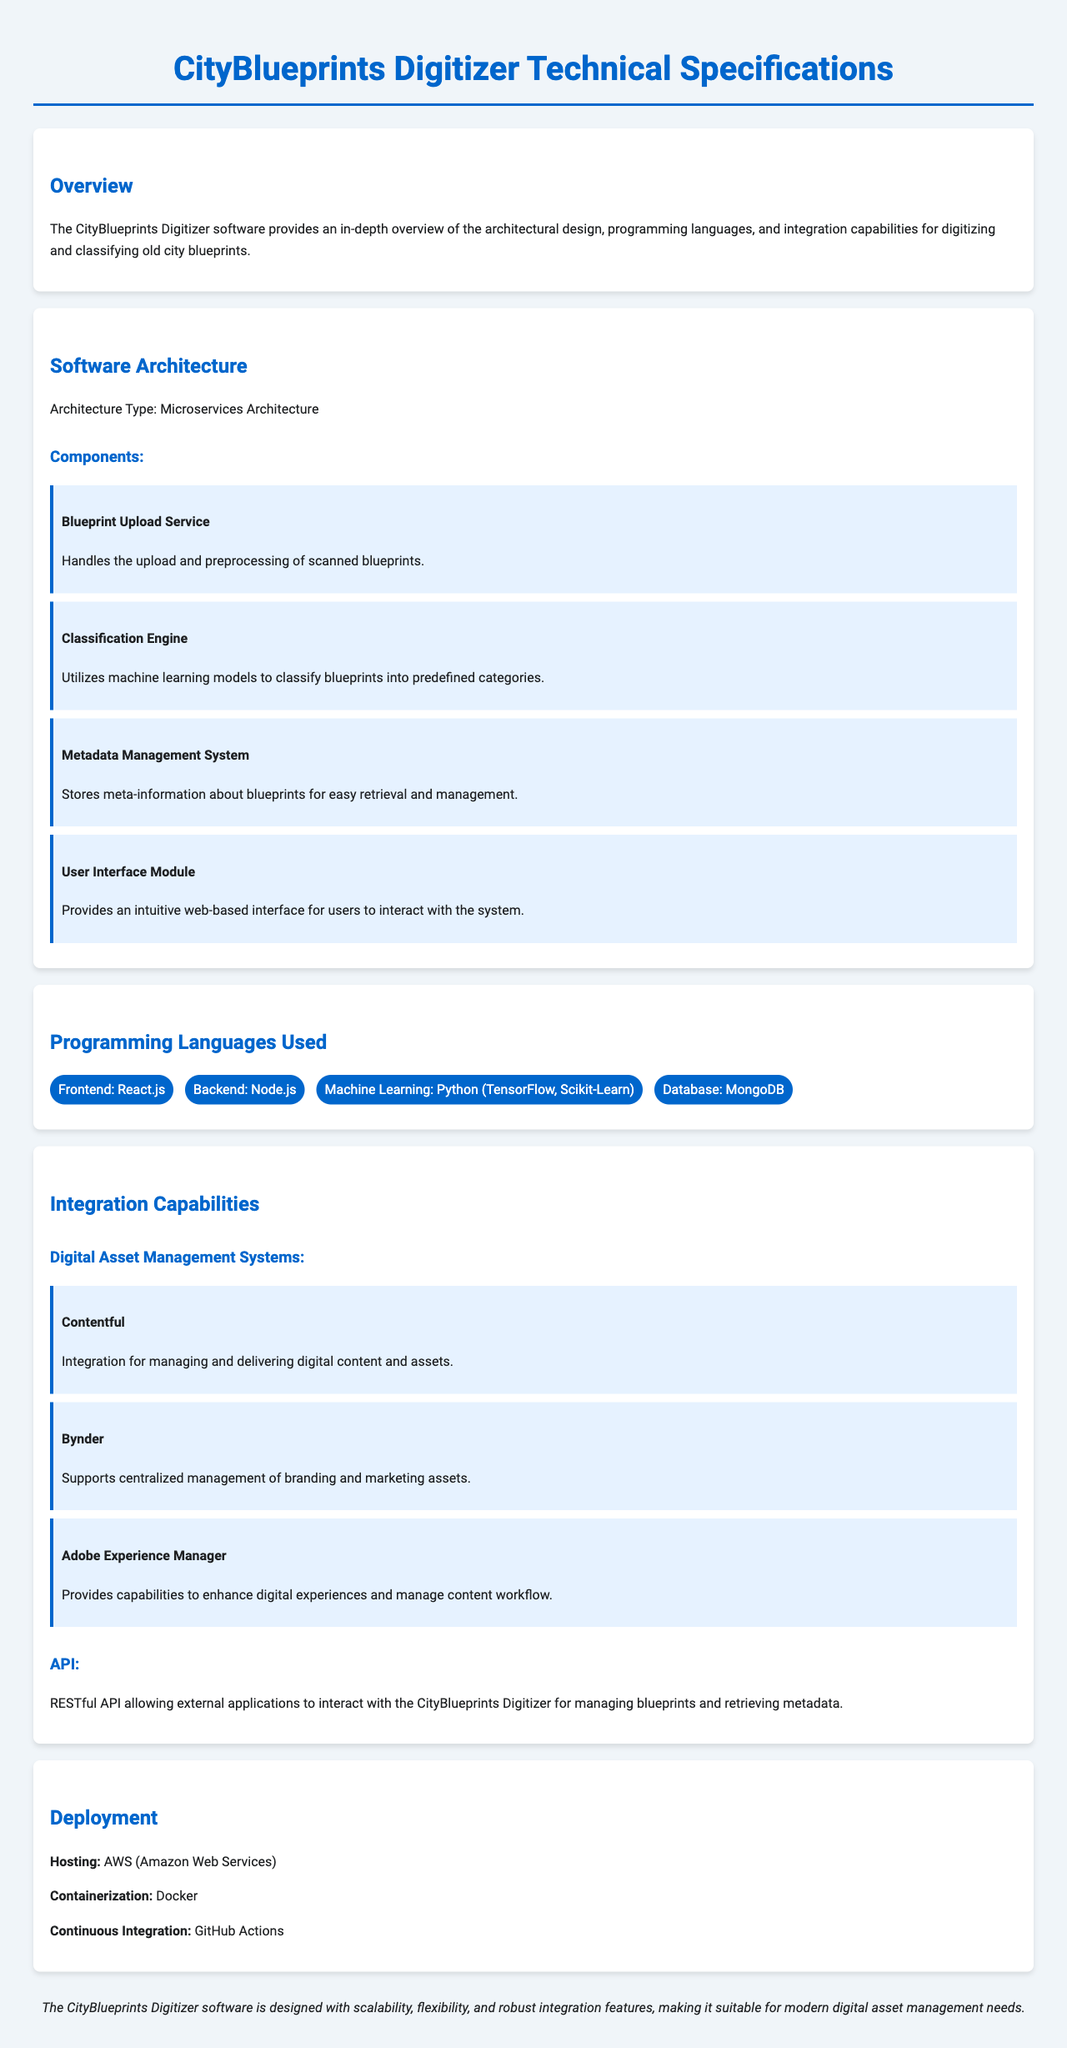What type of architecture does the software utilize? The document specifies "Microservices Architecture" as the architecture type used in the software.
Answer: Microservices Architecture What programming language is used for the frontend? The document lists "React.js" as the programming language for the frontend development of the software.
Answer: React.js Which service handles the upload of scanned blueprints? The document mentions the "Blueprint Upload Service" as the component responsible for handling the upload of scanned blueprints.
Answer: Blueprint Upload Service What digital asset management system is integrated for managing digital content? The document highlights "Contentful" as the digital asset management system integrated for managing and delivering digital content.
Answer: Contentful Which cloud service is used for hosting the software? The document indicates that the software is hosted on "AWS (Amazon Web Services)".
Answer: AWS How many integration capabilities are listed under Digital Asset Management Systems? Counting the systems listed in the document, there are three mentioned under Digital Asset Management Systems.
Answer: 3 What is used for continuous integration in the deployment setup? The document states that "GitHub Actions" is used for continuous integration in the deployment process.
Answer: GitHub Actions What role does the Classification Engine serve? The Classification Engine "utilizes machine learning models to classify blueprints into predefined categories."
Answer: Classifies blueprints What database technology is mentioned in the document? The document states that "MongoDB" is the database technology being used in the software implementation.
Answer: MongoDB 